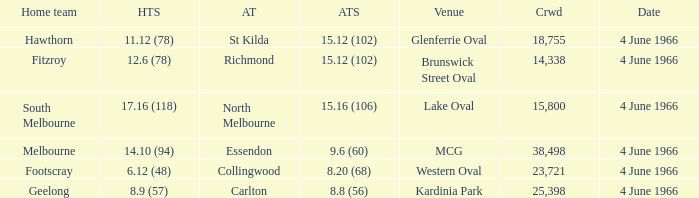What is the score of the away team that played home team Geelong? 8.8 (56). Give me the full table as a dictionary. {'header': ['Home team', 'HTS', 'AT', 'ATS', 'Venue', 'Crwd', 'Date'], 'rows': [['Hawthorn', '11.12 (78)', 'St Kilda', '15.12 (102)', 'Glenferrie Oval', '18,755', '4 June 1966'], ['Fitzroy', '12.6 (78)', 'Richmond', '15.12 (102)', 'Brunswick Street Oval', '14,338', '4 June 1966'], ['South Melbourne', '17.16 (118)', 'North Melbourne', '15.16 (106)', 'Lake Oval', '15,800', '4 June 1966'], ['Melbourne', '14.10 (94)', 'Essendon', '9.6 (60)', 'MCG', '38,498', '4 June 1966'], ['Footscray', '6.12 (48)', 'Collingwood', '8.20 (68)', 'Western Oval', '23,721', '4 June 1966'], ['Geelong', '8.9 (57)', 'Carlton', '8.8 (56)', 'Kardinia Park', '25,398', '4 June 1966']]} 